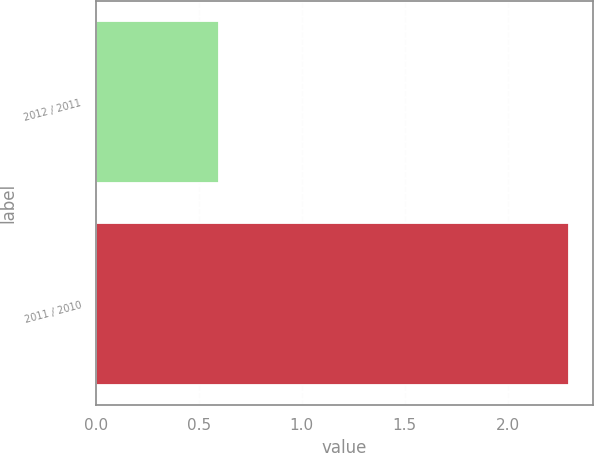Convert chart to OTSL. <chart><loc_0><loc_0><loc_500><loc_500><bar_chart><fcel>2012 / 2011<fcel>2011 / 2010<nl><fcel>0.6<fcel>2.3<nl></chart> 